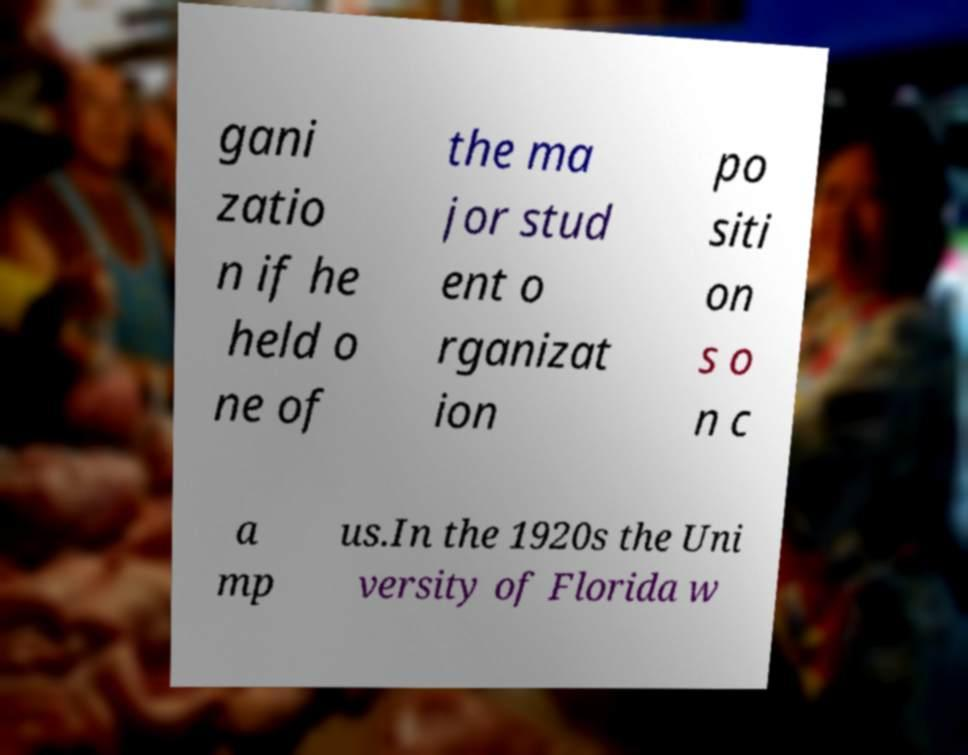Please identify and transcribe the text found in this image. gani zatio n if he held o ne of the ma jor stud ent o rganizat ion po siti on s o n c a mp us.In the 1920s the Uni versity of Florida w 